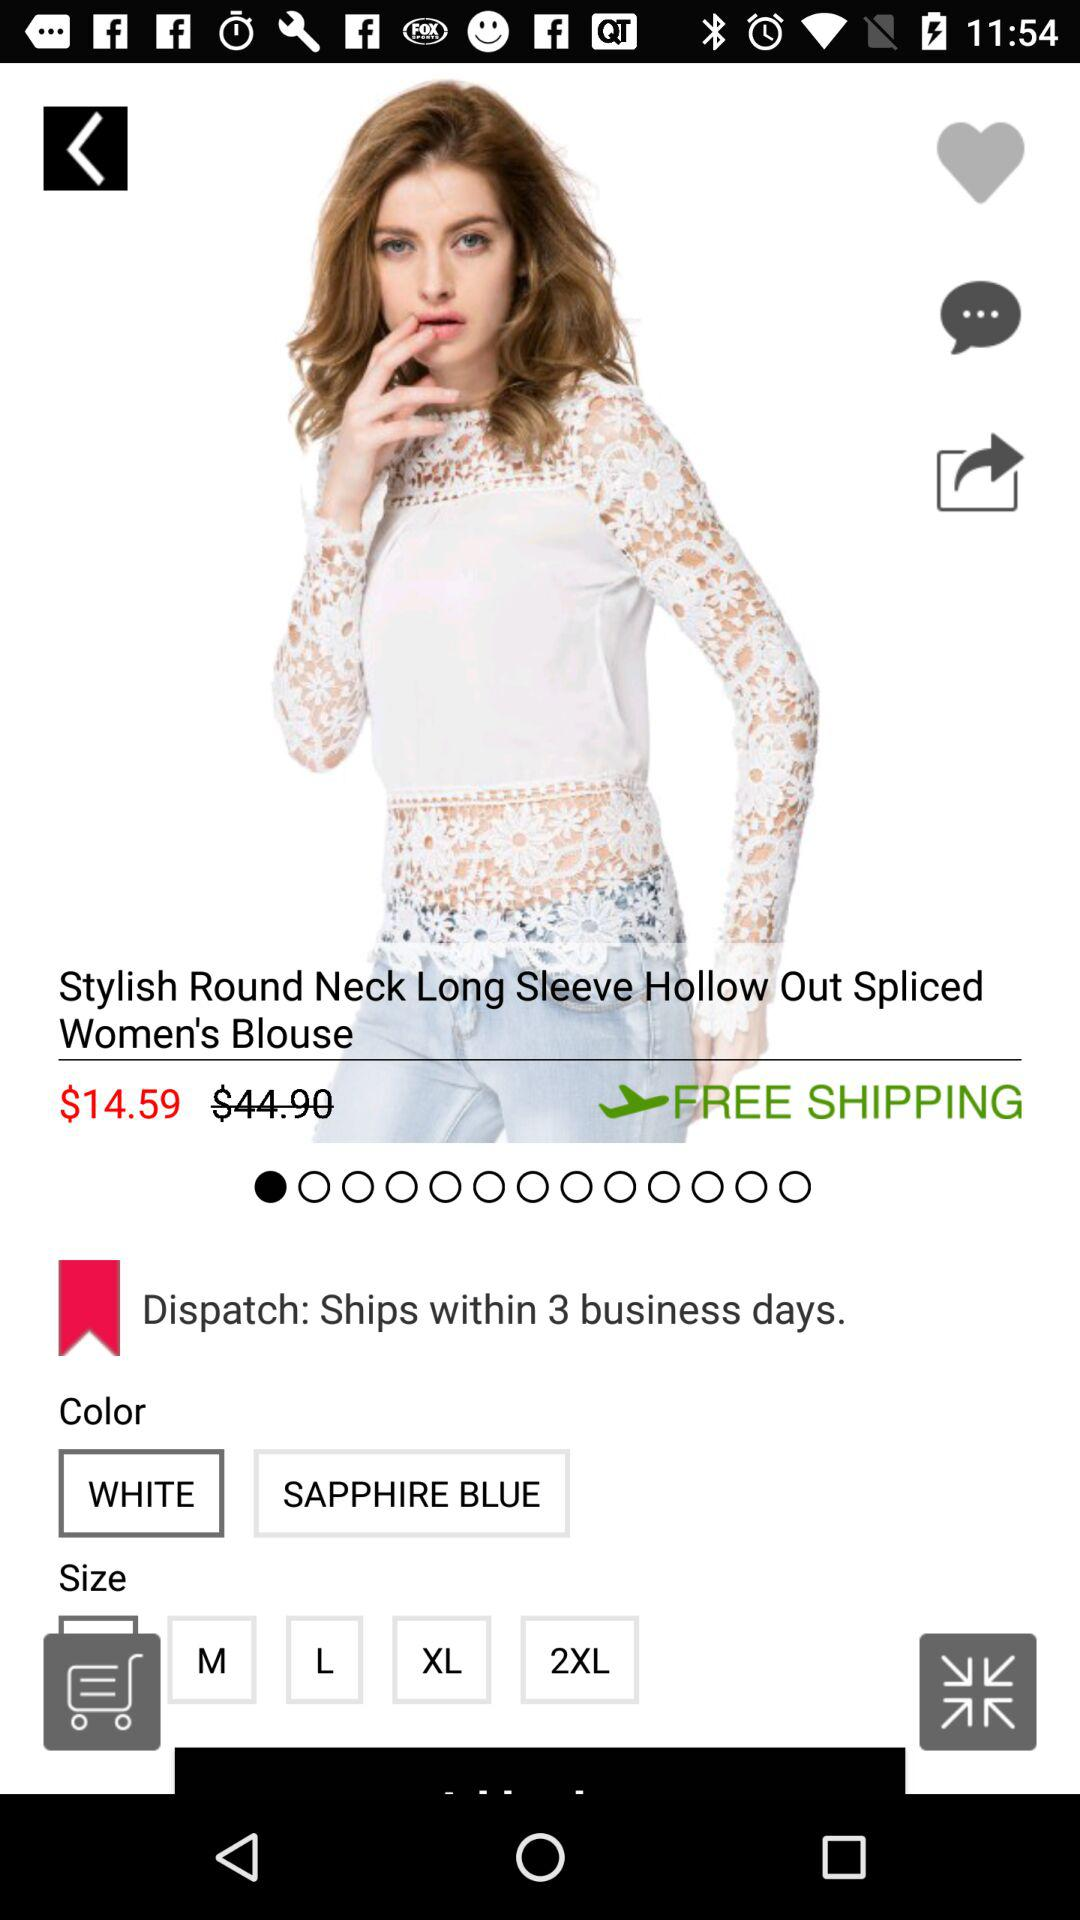In how many days will the product ship? The product will ship within 3 business days. 